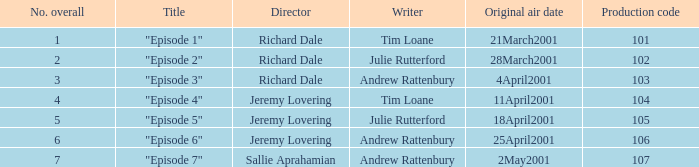When did the episodes first air that had a production code of 107? 2May2001. 